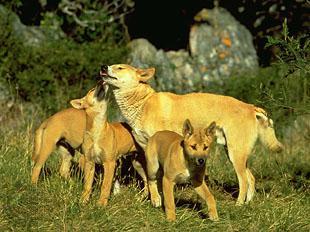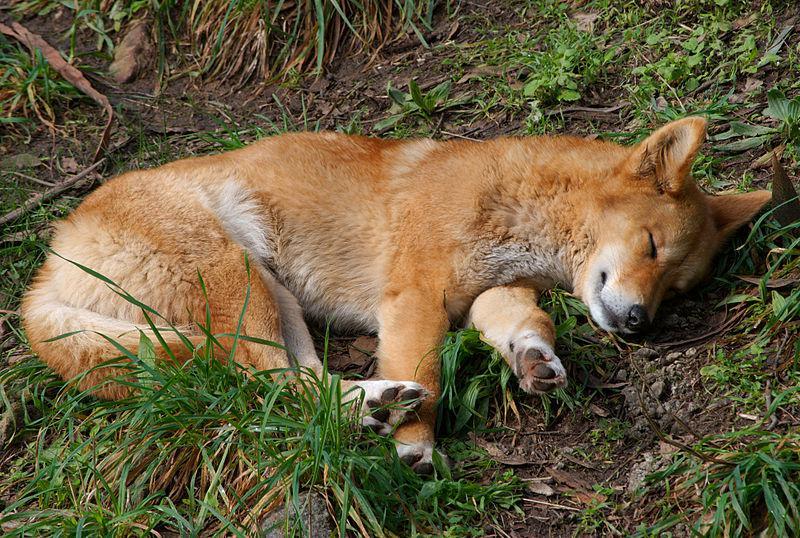The first image is the image on the left, the second image is the image on the right. Evaluate the accuracy of this statement regarding the images: "An image includes an adult dingo standing by at least three juvenile dogs.". Is it true? Answer yes or no. Yes. The first image is the image on the left, the second image is the image on the right. For the images displayed, is the sentence "There are exactly two wild dogs." factually correct? Answer yes or no. No. 